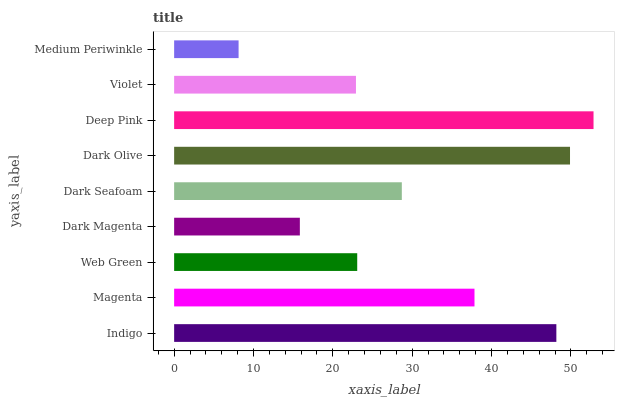Is Medium Periwinkle the minimum?
Answer yes or no. Yes. Is Deep Pink the maximum?
Answer yes or no. Yes. Is Magenta the minimum?
Answer yes or no. No. Is Magenta the maximum?
Answer yes or no. No. Is Indigo greater than Magenta?
Answer yes or no. Yes. Is Magenta less than Indigo?
Answer yes or no. Yes. Is Magenta greater than Indigo?
Answer yes or no. No. Is Indigo less than Magenta?
Answer yes or no. No. Is Dark Seafoam the high median?
Answer yes or no. Yes. Is Dark Seafoam the low median?
Answer yes or no. Yes. Is Magenta the high median?
Answer yes or no. No. Is Web Green the low median?
Answer yes or no. No. 